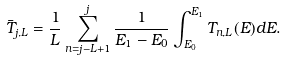<formula> <loc_0><loc_0><loc_500><loc_500>\bar { T } _ { j , L } = \frac { 1 } { L } \sum _ { n = j - L + 1 } ^ { j } \frac { 1 } { E _ { 1 } - E _ { 0 } } \int ^ { E _ { 1 } } _ { E _ { 0 } } T _ { n , L } ( E ) d E .</formula> 